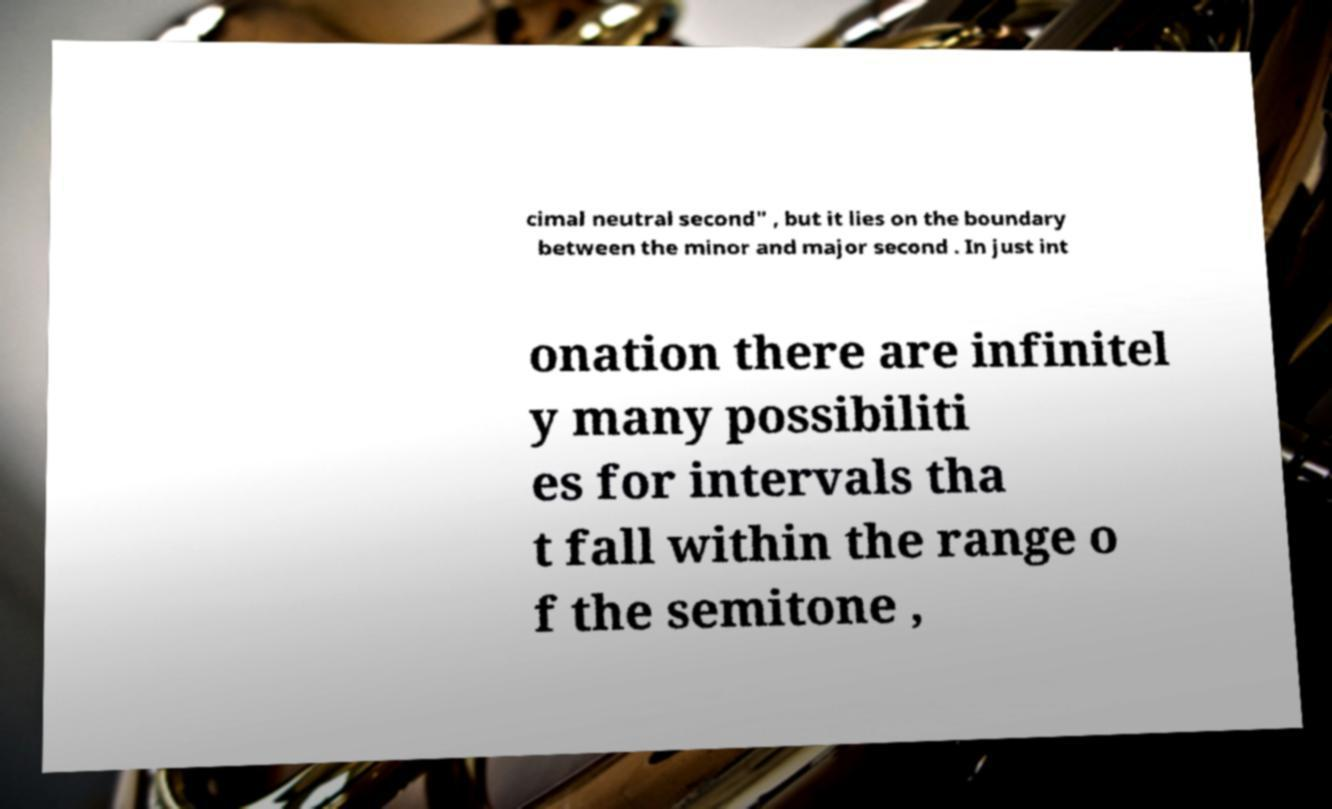Can you read and provide the text displayed in the image?This photo seems to have some interesting text. Can you extract and type it out for me? cimal neutral second" , but it lies on the boundary between the minor and major second . In just int onation there are infinitel y many possibiliti es for intervals tha t fall within the range o f the semitone , 